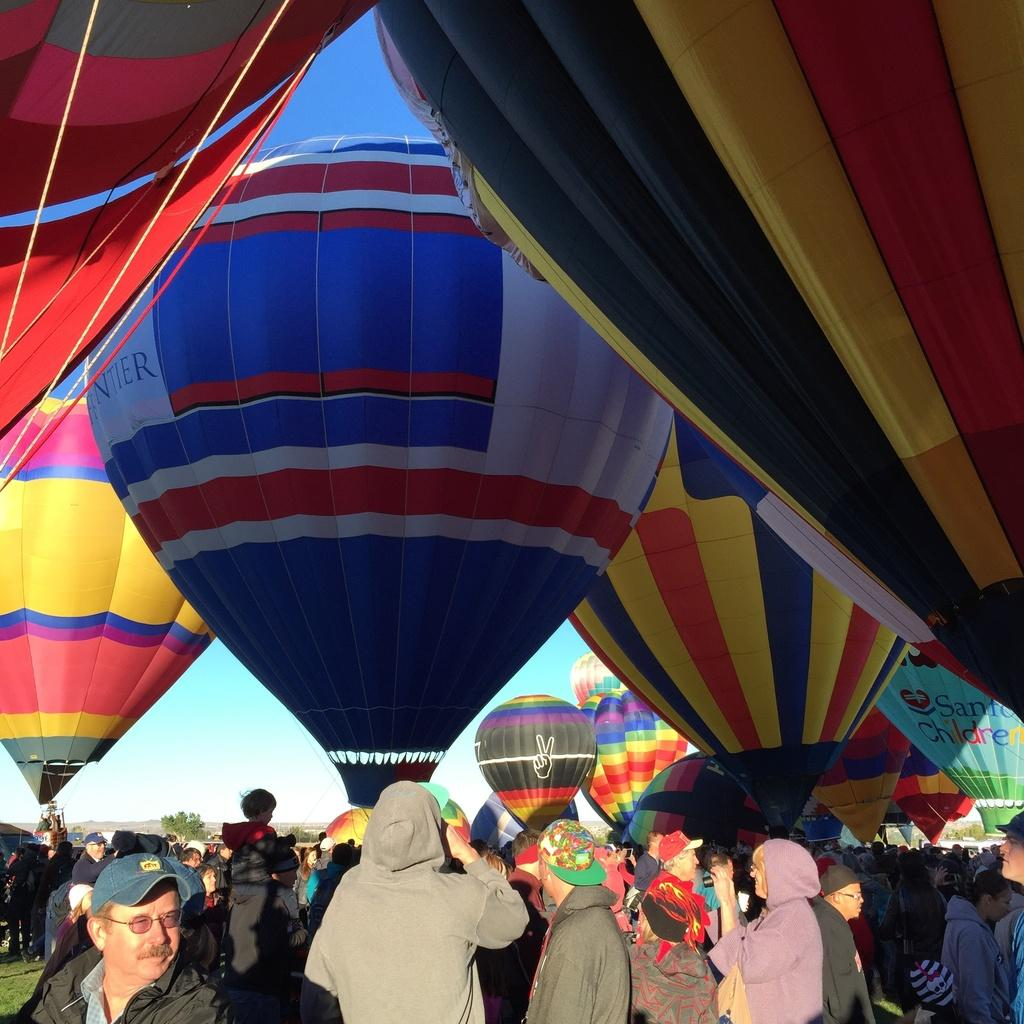What objects are featured in the image that are used for descending from a height? There are parachutes in the image that are used for descending from a height. How can the parachutes be distinguished from one another? The parachutes are in different colors, allowing them to be distinguished from one another. Who is present in the image? There are people in the image. What can be seen in the background of the image? Trees are visible in the background of the image. What is the color of the sky in the image? The sky is blue and white in color. What type of pencil is being used by the people in the image to conduct scientific experiments? There is no pencil or scientific experiment present in the image; it features parachutes and people. 